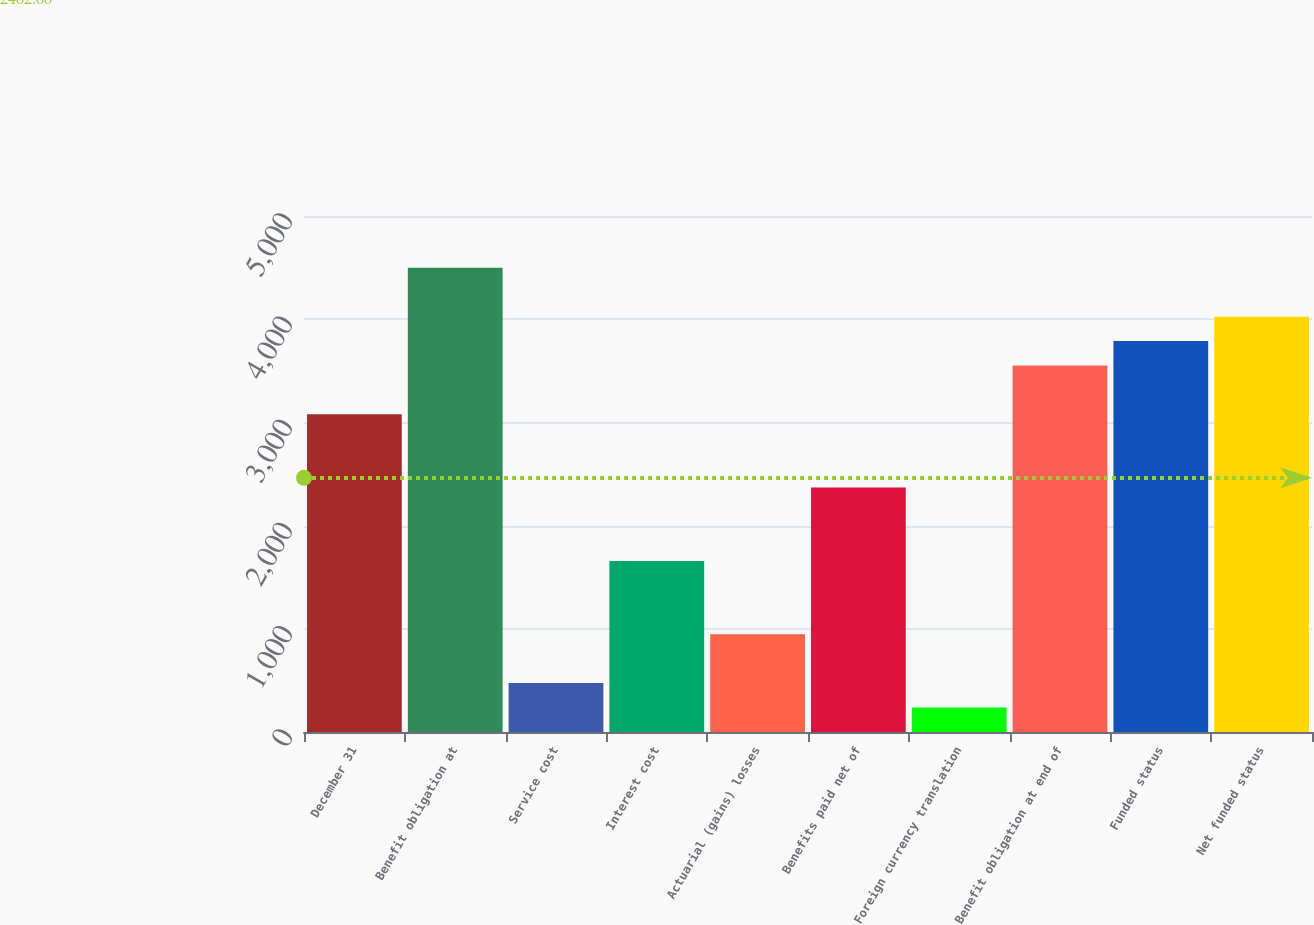<chart> <loc_0><loc_0><loc_500><loc_500><bar_chart><fcel>December 31<fcel>Benefit obligation at<fcel>Service cost<fcel>Interest cost<fcel>Actuarial (gains) losses<fcel>Benefits paid net of<fcel>Foreign currency translation<fcel>Benefit obligation at end of<fcel>Funded status<fcel>Net funded status<nl><fcel>3078.1<fcel>4498.3<fcel>474.4<fcel>1657.9<fcel>947.8<fcel>2368<fcel>237.7<fcel>3551.5<fcel>3788.2<fcel>4024.9<nl></chart> 